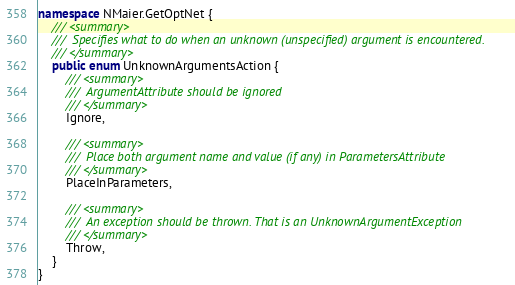Convert code to text. <code><loc_0><loc_0><loc_500><loc_500><_C#_>namespace NMaier.GetOptNet {
	/// <summary>
	///  Specifies what to do when an unknown (unspecified) argument is encountered.
	/// </summary>
	public enum UnknownArgumentsAction {
		/// <summary>
		///  ArgumentAttribute should be ignored
		/// </summary>
		Ignore,

		/// <summary>
		///  Place both argument name and value (if any) in ParametersAttribute
		/// </summary>
		PlaceInParameters,

		/// <summary>
		///  An exception should be thrown. That is an UnknownArgumentException
		/// </summary>
		Throw,
	}
}
</code> 